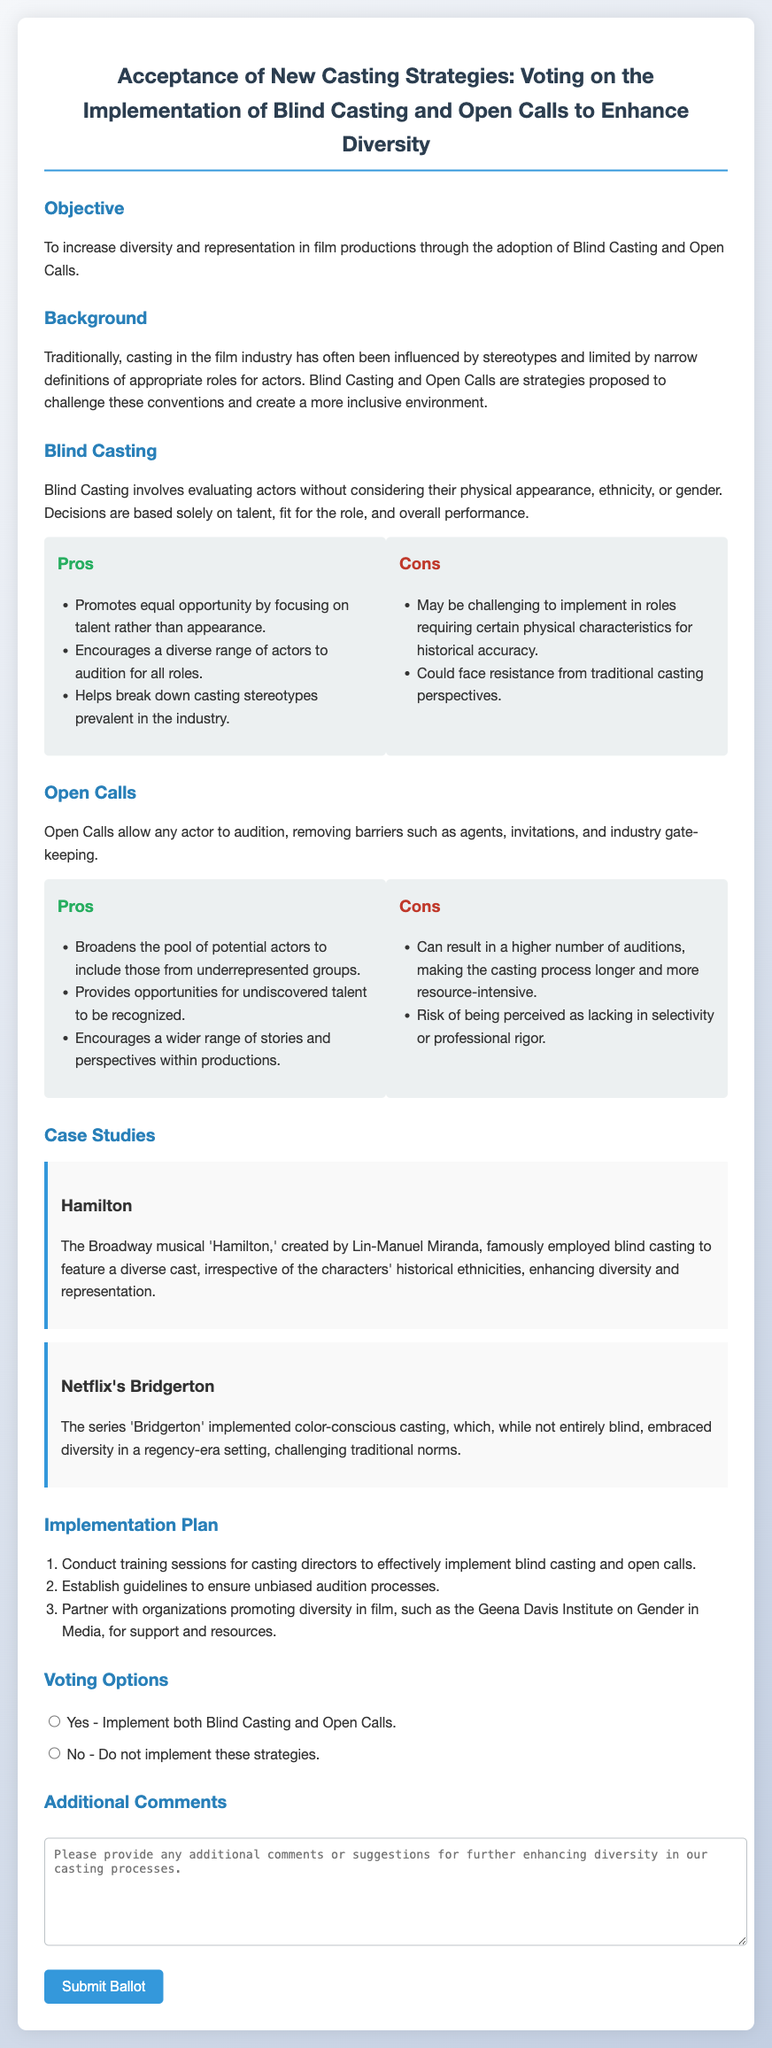What is the objective of the ballot? The objective is clearly stated in the document as increasing diversity and representation in film productions through the adoption of Blind Casting and Open Calls.
Answer: Increase diversity and representation What is Blind Casting? The document defines Blind Casting as evaluating actors without considering their physical appearance, ethnicity, or gender, focusing solely on talent and performance.
Answer: Evaluating actors without appearance or ethnicity What is one pro of Open Calls? The document lists that one pro of Open Calls is that they broaden the pool of potential actors to include those from underrepresented groups.
Answer: Broadens the pool of potential actors How many case studies are presented in the document? The document presents two case studies, "Hamilton" and "Netflix's Bridgerton."
Answer: Two What does the implementation plan suggest as the first step? The first step outlined in the implementation plan is to conduct training sessions for casting directors to effectively implement blind casting and open calls.
Answer: Conduct training sessions What is the voting option for implementing both strategies? The document indicates that the option to implement both Blind Casting and Open Calls is a "Yes" vote.
Answer: Yes - Implement both strategies Which organization is mentioned as a partner for supporting diverse casting? The Geena Davis Institute on Gender in Media is mentioned as a partner organization for support and resources.
Answer: Geena Davis Institute on Gender in Media What are the two strategies proposed in the ballot? The document specifies that the two strategies proposed are Blind Casting and Open Calls.
Answer: Blind Casting and Open Calls 